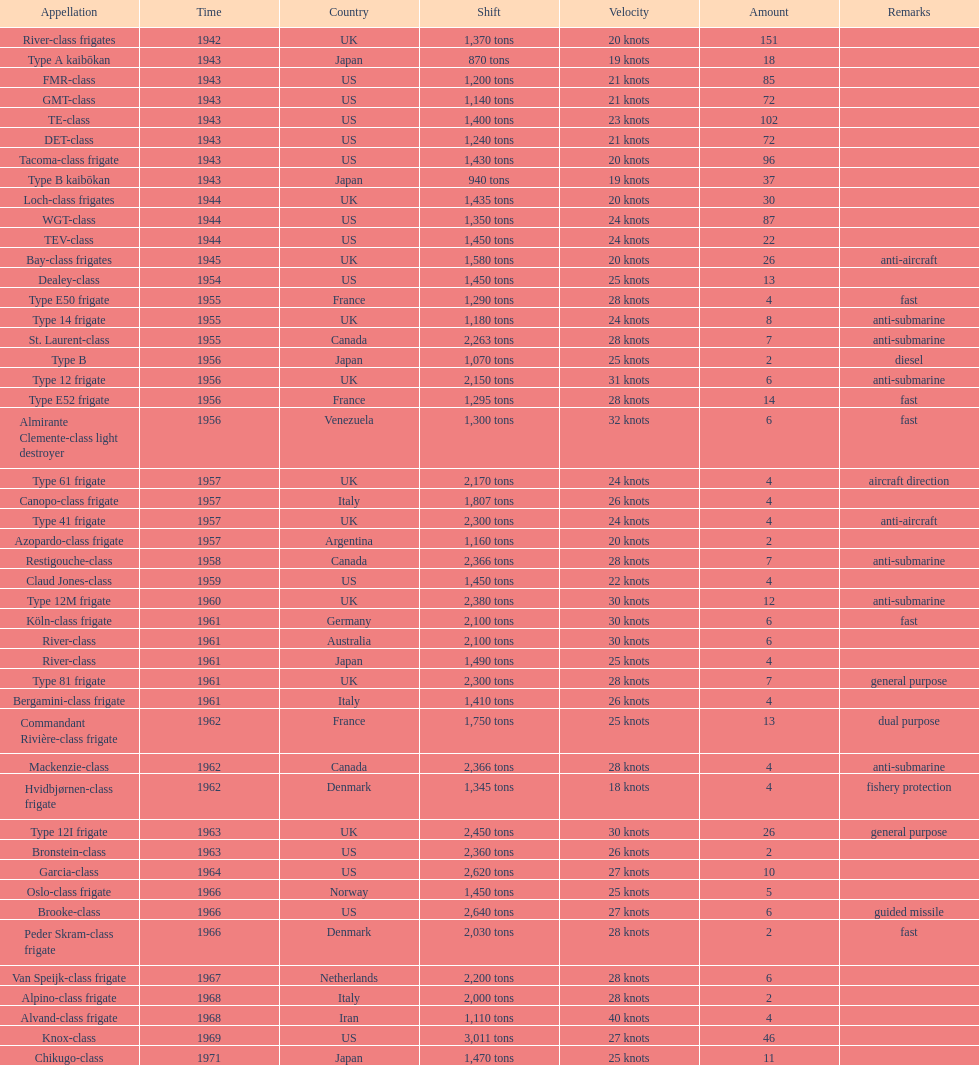Could you parse the entire table? {'header': ['Appellation', 'Time', 'Country', 'Shift', 'Velocity', 'Amount', 'Remarks'], 'rows': [['River-class frigates', '1942', 'UK', '1,370 tons', '20 knots', '151', ''], ['Type A kaibōkan', '1943', 'Japan', '870 tons', '19 knots', '18', ''], ['FMR-class', '1943', 'US', '1,200 tons', '21 knots', '85', ''], ['GMT-class', '1943', 'US', '1,140 tons', '21 knots', '72', ''], ['TE-class', '1943', 'US', '1,400 tons', '23 knots', '102', ''], ['DET-class', '1943', 'US', '1,240 tons', '21 knots', '72', ''], ['Tacoma-class frigate', '1943', 'US', '1,430 tons', '20 knots', '96', ''], ['Type B kaibōkan', '1943', 'Japan', '940 tons', '19 knots', '37', ''], ['Loch-class frigates', '1944', 'UK', '1,435 tons', '20 knots', '30', ''], ['WGT-class', '1944', 'US', '1,350 tons', '24 knots', '87', ''], ['TEV-class', '1944', 'US', '1,450 tons', '24 knots', '22', ''], ['Bay-class frigates', '1945', 'UK', '1,580 tons', '20 knots', '26', 'anti-aircraft'], ['Dealey-class', '1954', 'US', '1,450 tons', '25 knots', '13', ''], ['Type E50 frigate', '1955', 'France', '1,290 tons', '28 knots', '4', 'fast'], ['Type 14 frigate', '1955', 'UK', '1,180 tons', '24 knots', '8', 'anti-submarine'], ['St. Laurent-class', '1955', 'Canada', '2,263 tons', '28 knots', '7', 'anti-submarine'], ['Type B', '1956', 'Japan', '1,070 tons', '25 knots', '2', 'diesel'], ['Type 12 frigate', '1956', 'UK', '2,150 tons', '31 knots', '6', 'anti-submarine'], ['Type E52 frigate', '1956', 'France', '1,295 tons', '28 knots', '14', 'fast'], ['Almirante Clemente-class light destroyer', '1956', 'Venezuela', '1,300 tons', '32 knots', '6', 'fast'], ['Type 61 frigate', '1957', 'UK', '2,170 tons', '24 knots', '4', 'aircraft direction'], ['Canopo-class frigate', '1957', 'Italy', '1,807 tons', '26 knots', '4', ''], ['Type 41 frigate', '1957', 'UK', '2,300 tons', '24 knots', '4', 'anti-aircraft'], ['Azopardo-class frigate', '1957', 'Argentina', '1,160 tons', '20 knots', '2', ''], ['Restigouche-class', '1958', 'Canada', '2,366 tons', '28 knots', '7', 'anti-submarine'], ['Claud Jones-class', '1959', 'US', '1,450 tons', '22 knots', '4', ''], ['Type 12M frigate', '1960', 'UK', '2,380 tons', '30 knots', '12', 'anti-submarine'], ['Köln-class frigate', '1961', 'Germany', '2,100 tons', '30 knots', '6', 'fast'], ['River-class', '1961', 'Australia', '2,100 tons', '30 knots', '6', ''], ['River-class', '1961', 'Japan', '1,490 tons', '25 knots', '4', ''], ['Type 81 frigate', '1961', 'UK', '2,300 tons', '28 knots', '7', 'general purpose'], ['Bergamini-class frigate', '1961', 'Italy', '1,410 tons', '26 knots', '4', ''], ['Commandant Rivière-class frigate', '1962', 'France', '1,750 tons', '25 knots', '13', 'dual purpose'], ['Mackenzie-class', '1962', 'Canada', '2,366 tons', '28 knots', '4', 'anti-submarine'], ['Hvidbjørnen-class frigate', '1962', 'Denmark', '1,345 tons', '18 knots', '4', 'fishery protection'], ['Type 12I frigate', '1963', 'UK', '2,450 tons', '30 knots', '26', 'general purpose'], ['Bronstein-class', '1963', 'US', '2,360 tons', '26 knots', '2', ''], ['Garcia-class', '1964', 'US', '2,620 tons', '27 knots', '10', ''], ['Oslo-class frigate', '1966', 'Norway', '1,450 tons', '25 knots', '5', ''], ['Brooke-class', '1966', 'US', '2,640 tons', '27 knots', '6', 'guided missile'], ['Peder Skram-class frigate', '1966', 'Denmark', '2,030 tons', '28 knots', '2', 'fast'], ['Van Speijk-class frigate', '1967', 'Netherlands', '2,200 tons', '28 knots', '6', ''], ['Alpino-class frigate', '1968', 'Italy', '2,000 tons', '28 knots', '2', ''], ['Alvand-class frigate', '1968', 'Iran', '1,110 tons', '40 knots', '4', ''], ['Knox-class', '1969', 'US', '3,011 tons', '27 knots', '46', ''], ['Chikugo-class', '1971', 'Japan', '1,470 tons', '25 knots', '11', '']]} Which of the boats listed is the fastest? Alvand-class frigate. 